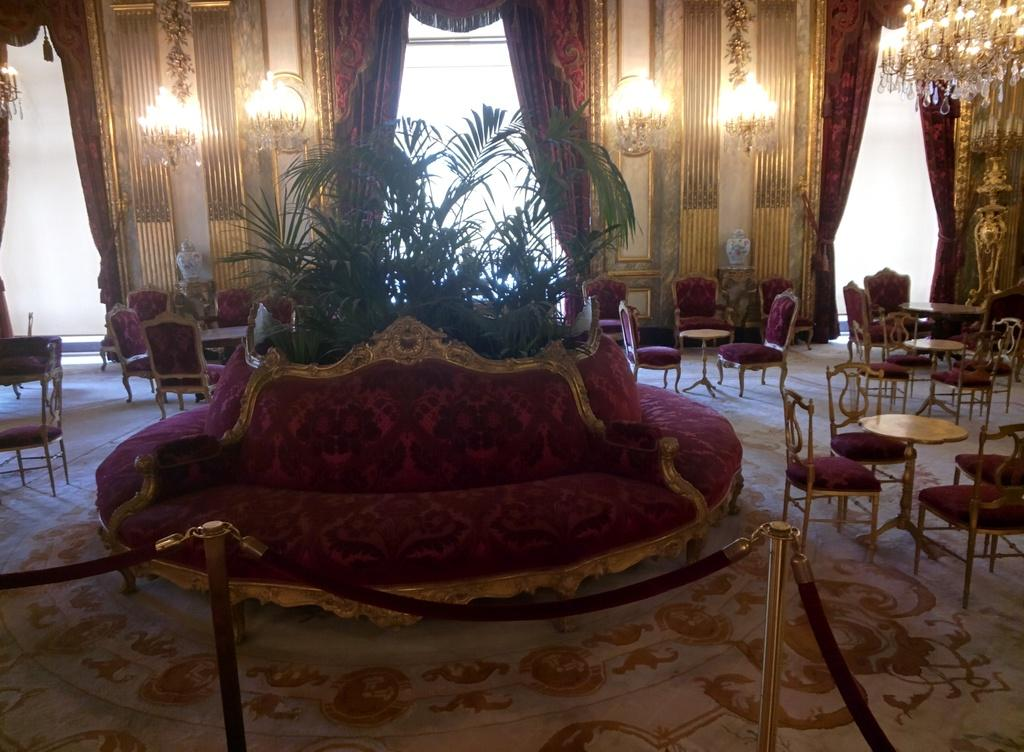What type of window treatment is present in the image? There is a curtain in the image. What can be seen providing illumination in the image? There are lights in the image. What type of greenery is visible in the image? There are plants in the image. What type of furniture is present for seating in the image? There are chairs in the image. What type of furniture is present for placing items in the image? There are tables in the image. Can you see a snake rubbing against the curtain in the image? There is no snake present in the image, nor is there any indication of a snake rubbing against the curtain. Is there a collar visible on any of the plants in the image? There are no collars present on any of the plants in the image, as plants do not wear collars. 